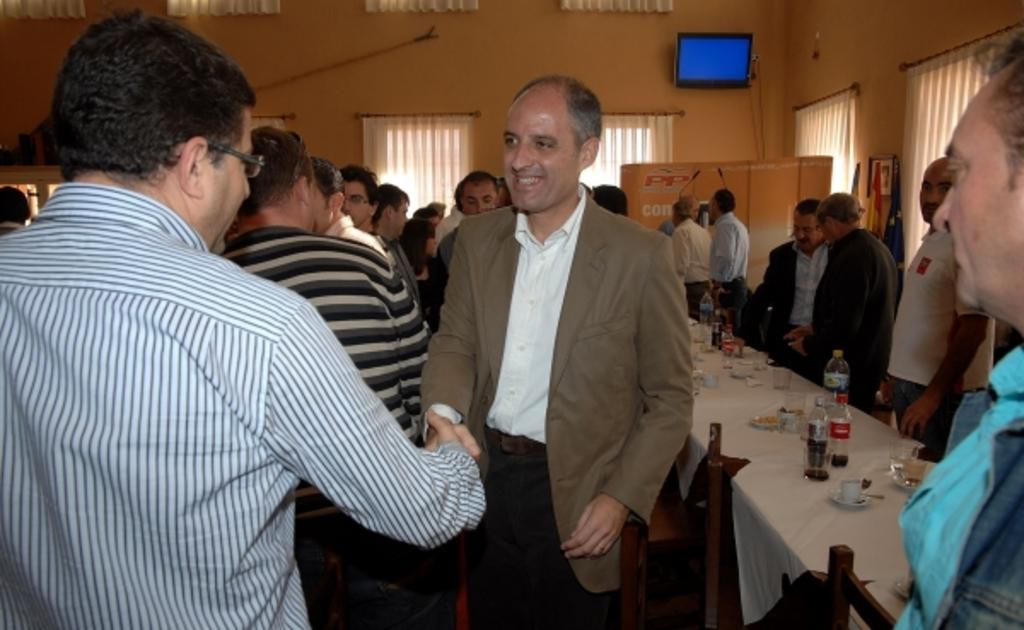How many people are in the image? There are persons in the image, but the exact number is not specified. What type of containers can be seen in the image? There are bottles and glasses in the image. What type of furniture is present in the image? There are chairs and tables in the image. What can be seen in the background of the image? There is a wall, curtains, a screen, and other objects in the background of the image. How does the song being played in the image affect the zipper on the chair? There is no mention of a song or a zipper on a chair in the image, so this question cannot be answered. 